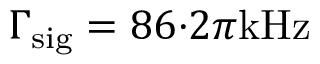<formula> <loc_0><loc_0><loc_500><loc_500>\Gamma _ { s i g } = 8 6 { \cdot } 2 \pi k H z</formula> 